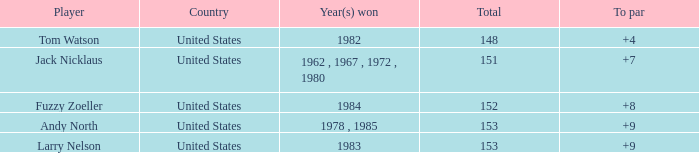What is the sum for the player who won in the year 1982? 148.0. 